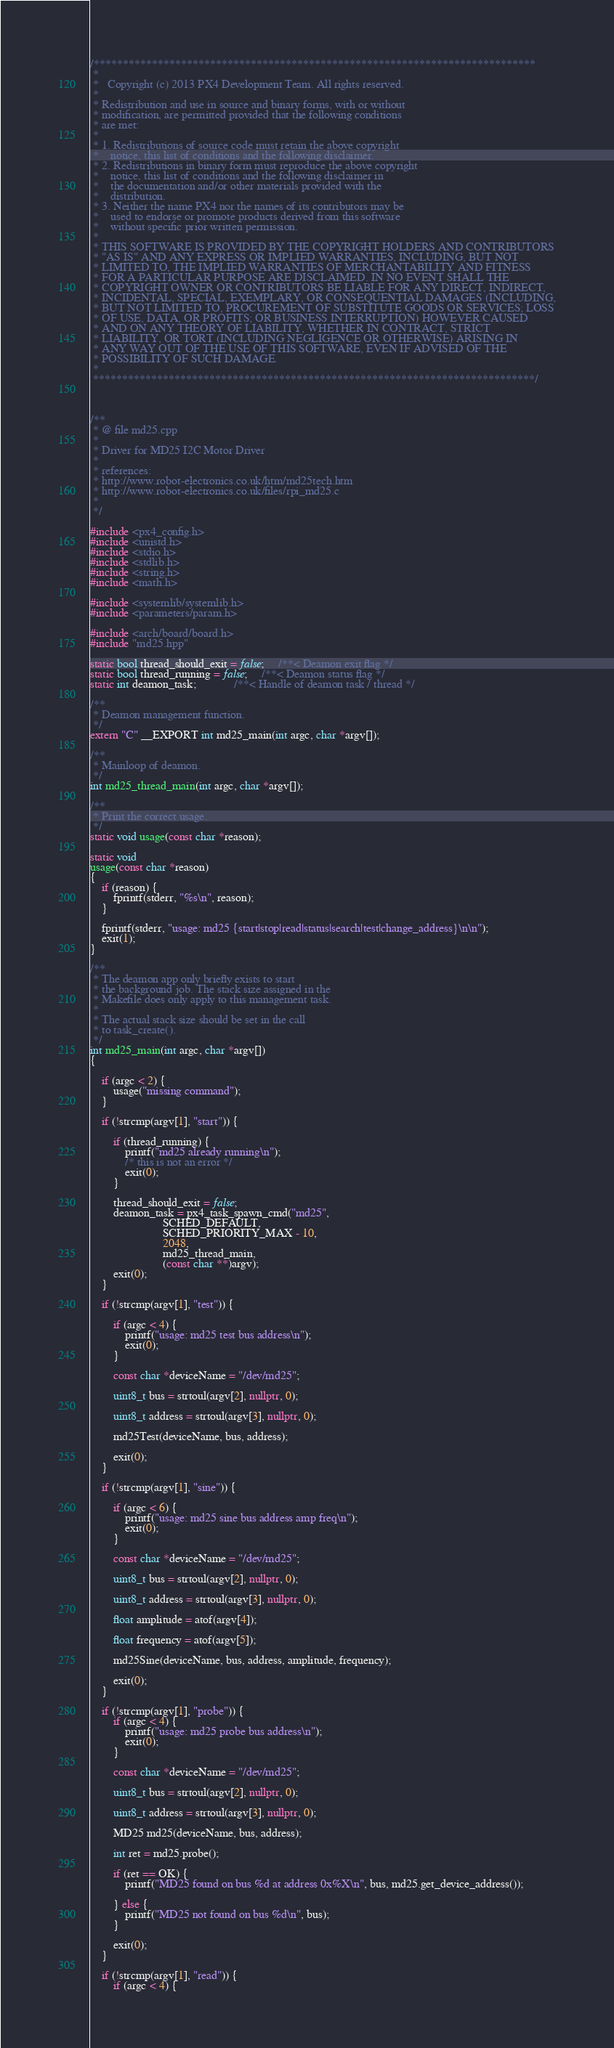<code> <loc_0><loc_0><loc_500><loc_500><_C++_>/****************************************************************************
 *
 *   Copyright (c) 2013 PX4 Development Team. All rights reserved.
 *
 * Redistribution and use in source and binary forms, with or without
 * modification, are permitted provided that the following conditions
 * are met:
 *
 * 1. Redistributions of source code must retain the above copyright
 *    notice, this list of conditions and the following disclaimer.
 * 2. Redistributions in binary form must reproduce the above copyright
 *    notice, this list of conditions and the following disclaimer in
 *    the documentation and/or other materials provided with the
 *    distribution.
 * 3. Neither the name PX4 nor the names of its contributors may be
 *    used to endorse or promote products derived from this software
 *    without specific prior written permission.
 *
 * THIS SOFTWARE IS PROVIDED BY THE COPYRIGHT HOLDERS AND CONTRIBUTORS
 * "AS IS" AND ANY EXPRESS OR IMPLIED WARRANTIES, INCLUDING, BUT NOT
 * LIMITED TO, THE IMPLIED WARRANTIES OF MERCHANTABILITY AND FITNESS
 * FOR A PARTICULAR PURPOSE ARE DISCLAIMED. IN NO EVENT SHALL THE
 * COPYRIGHT OWNER OR CONTRIBUTORS BE LIABLE FOR ANY DIRECT, INDIRECT,
 * INCIDENTAL, SPECIAL, EXEMPLARY, OR CONSEQUENTIAL DAMAGES (INCLUDING,
 * BUT NOT LIMITED TO, PROCUREMENT OF SUBSTITUTE GOODS OR SERVICES; LOSS
 * OF USE, DATA, OR PROFITS; OR BUSINESS INTERRUPTION) HOWEVER CAUSED
 * AND ON ANY THEORY OF LIABILITY, WHETHER IN CONTRACT, STRICT
 * LIABILITY, OR TORT (INCLUDING NEGLIGENCE OR OTHERWISE) ARISING IN
 * ANY WAY OUT OF THE USE OF THIS SOFTWARE, EVEN IF ADVISED OF THE
 * POSSIBILITY OF SUCH DAMAGE.
 *
 ****************************************************************************/



/**
 * @ file md25.cpp
 *
 * Driver for MD25 I2C Motor Driver
 *
 * references:
 * http://www.robot-electronics.co.uk/htm/md25tech.htm
 * http://www.robot-electronics.co.uk/files/rpi_md25.c
 *
 */

#include <px4_config.h>
#include <unistd.h>
#include <stdio.h>
#include <stdlib.h>
#include <string.h>
#include <math.h>

#include <systemlib/systemlib.h>
#include <parameters/param.h>

#include <arch/board/board.h>
#include "md25.hpp"

static bool thread_should_exit = false;     /**< Deamon exit flag */
static bool thread_running = false;     /**< Deamon status flag */
static int deamon_task;             /**< Handle of deamon task / thread */

/**
 * Deamon management function.
 */
extern "C" __EXPORT int md25_main(int argc, char *argv[]);

/**
 * Mainloop of deamon.
 */
int md25_thread_main(int argc, char *argv[]);

/**
 * Print the correct usage.
 */
static void usage(const char *reason);

static void
usage(const char *reason)
{
	if (reason) {
		fprintf(stderr, "%s\n", reason);
	}

	fprintf(stderr, "usage: md25 {start|stop|read|status|search|test|change_address}\n\n");
	exit(1);
}

/**
 * The deamon app only briefly exists to start
 * the background job. The stack size assigned in the
 * Makefile does only apply to this management task.
 *
 * The actual stack size should be set in the call
 * to task_create().
 */
int md25_main(int argc, char *argv[])
{

	if (argc < 2) {
		usage("missing command");
	}

	if (!strcmp(argv[1], "start")) {

		if (thread_running) {
			printf("md25 already running\n");
			/* this is not an error */
			exit(0);
		}

		thread_should_exit = false;
		deamon_task = px4_task_spawn_cmd("md25",
						 SCHED_DEFAULT,
						 SCHED_PRIORITY_MAX - 10,
						 2048,
						 md25_thread_main,
						 (const char **)argv);
		exit(0);
	}

	if (!strcmp(argv[1], "test")) {

		if (argc < 4) {
			printf("usage: md25 test bus address\n");
			exit(0);
		}

		const char *deviceName = "/dev/md25";

		uint8_t bus = strtoul(argv[2], nullptr, 0);

		uint8_t address = strtoul(argv[3], nullptr, 0);

		md25Test(deviceName, bus, address);

		exit(0);
	}

	if (!strcmp(argv[1], "sine")) {

		if (argc < 6) {
			printf("usage: md25 sine bus address amp freq\n");
			exit(0);
		}

		const char *deviceName = "/dev/md25";

		uint8_t bus = strtoul(argv[2], nullptr, 0);

		uint8_t address = strtoul(argv[3], nullptr, 0);

		float amplitude = atof(argv[4]);

		float frequency = atof(argv[5]);

		md25Sine(deviceName, bus, address, amplitude, frequency);

		exit(0);
	}

	if (!strcmp(argv[1], "probe")) {
		if (argc < 4) {
			printf("usage: md25 probe bus address\n");
			exit(0);
		}

		const char *deviceName = "/dev/md25";

		uint8_t bus = strtoul(argv[2], nullptr, 0);

		uint8_t address = strtoul(argv[3], nullptr, 0);

		MD25 md25(deviceName, bus, address);

		int ret = md25.probe();

		if (ret == OK) {
			printf("MD25 found on bus %d at address 0x%X\n", bus, md25.get_device_address());

		} else {
			printf("MD25 not found on bus %d\n", bus);
		}

		exit(0);
	}

	if (!strcmp(argv[1], "read")) {
		if (argc < 4) {</code> 